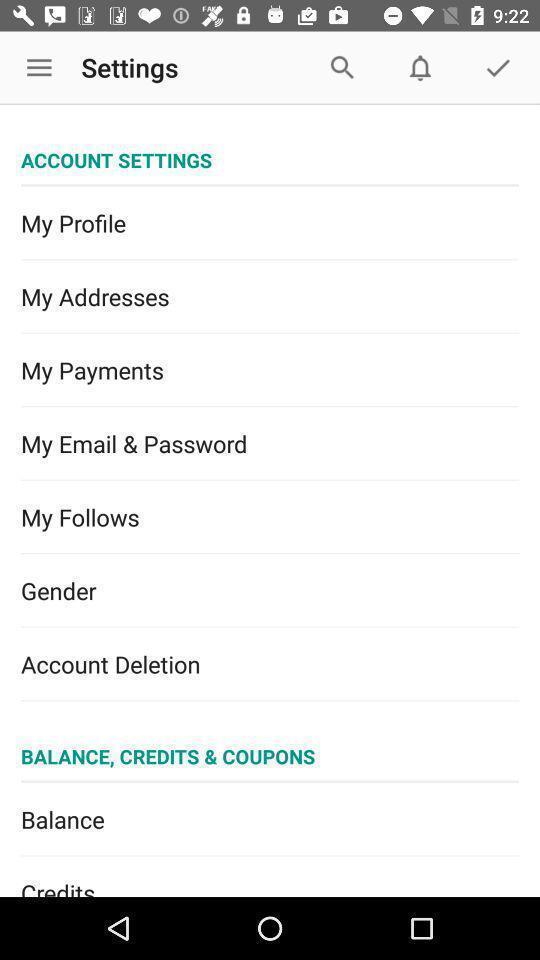Summarize the information in this screenshot. Settings page displayed. 